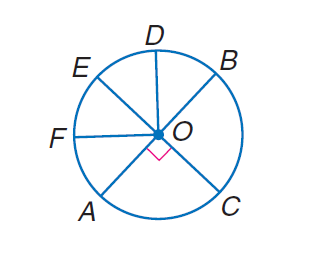Answer the mathemtical geometry problem and directly provide the correct option letter.
Question: In \odot O, E C and A B are diameters, and \angle B O D \cong \angle D O E \cong \angle E O F \cong \angle F O A. Find m \widehat E B.
Choices: A: 45 B: 90 C: 180 D: 360 B 